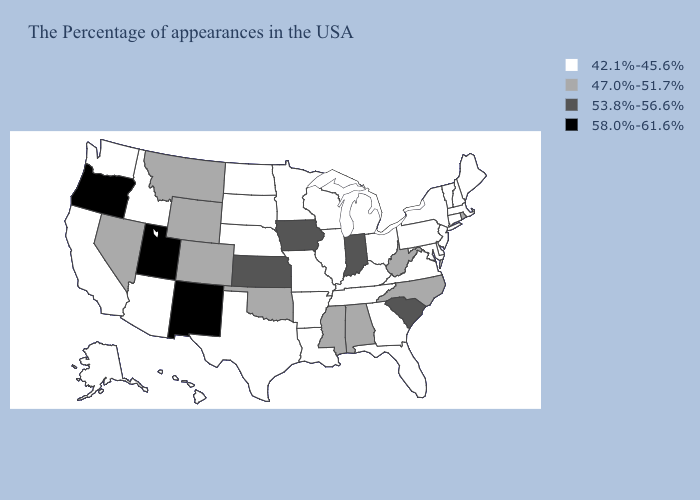Name the states that have a value in the range 58.0%-61.6%?
Answer briefly. New Mexico, Utah, Oregon. What is the highest value in the South ?
Be succinct. 53.8%-56.6%. Name the states that have a value in the range 58.0%-61.6%?
Answer briefly. New Mexico, Utah, Oregon. Among the states that border Kansas , which have the highest value?
Short answer required. Oklahoma, Colorado. Does the first symbol in the legend represent the smallest category?
Keep it brief. Yes. What is the lowest value in the West?
Write a very short answer. 42.1%-45.6%. What is the value of California?
Be succinct. 42.1%-45.6%. Name the states that have a value in the range 58.0%-61.6%?
Keep it brief. New Mexico, Utah, Oregon. Name the states that have a value in the range 53.8%-56.6%?
Short answer required. South Carolina, Indiana, Iowa, Kansas. Name the states that have a value in the range 47.0%-51.7%?
Quick response, please. Rhode Island, North Carolina, West Virginia, Alabama, Mississippi, Oklahoma, Wyoming, Colorado, Montana, Nevada. Which states have the lowest value in the South?
Concise answer only. Delaware, Maryland, Virginia, Florida, Georgia, Kentucky, Tennessee, Louisiana, Arkansas, Texas. Among the states that border West Virginia , which have the highest value?
Quick response, please. Maryland, Pennsylvania, Virginia, Ohio, Kentucky. What is the highest value in the USA?
Short answer required. 58.0%-61.6%. Among the states that border Massachusetts , which have the highest value?
Write a very short answer. Rhode Island. 